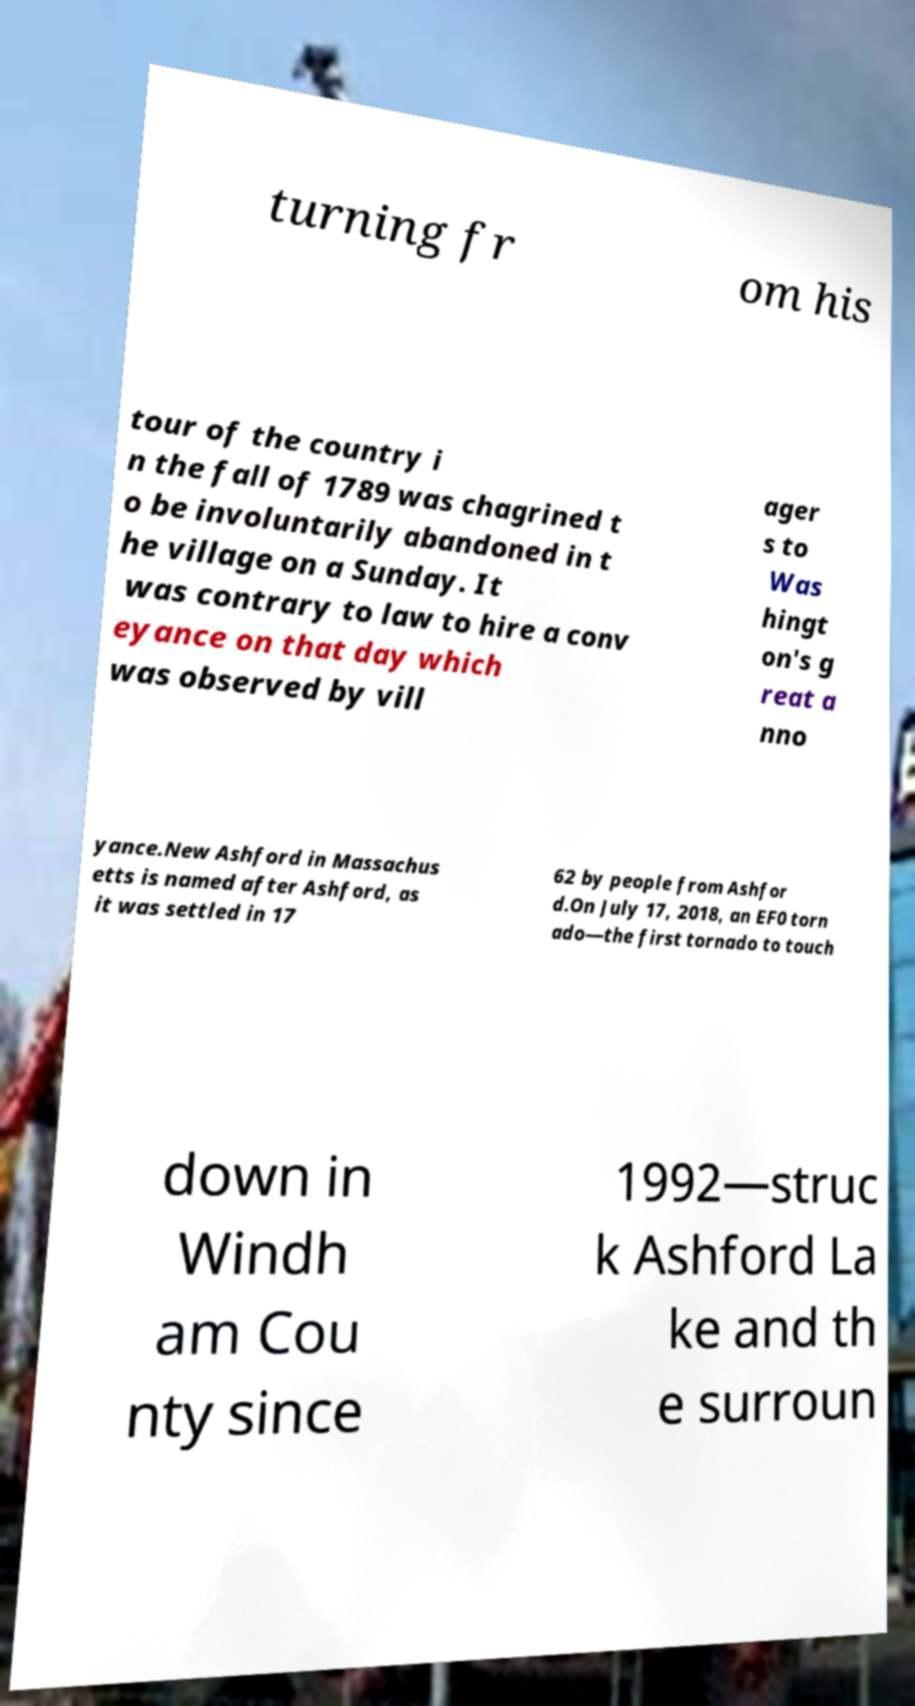There's text embedded in this image that I need extracted. Can you transcribe it verbatim? turning fr om his tour of the country i n the fall of 1789 was chagrined t o be involuntarily abandoned in t he village on a Sunday. It was contrary to law to hire a conv eyance on that day which was observed by vill ager s to Was hingt on's g reat a nno yance.New Ashford in Massachus etts is named after Ashford, as it was settled in 17 62 by people from Ashfor d.On July 17, 2018, an EF0 torn ado—the first tornado to touch down in Windh am Cou nty since 1992—struc k Ashford La ke and th e surroun 